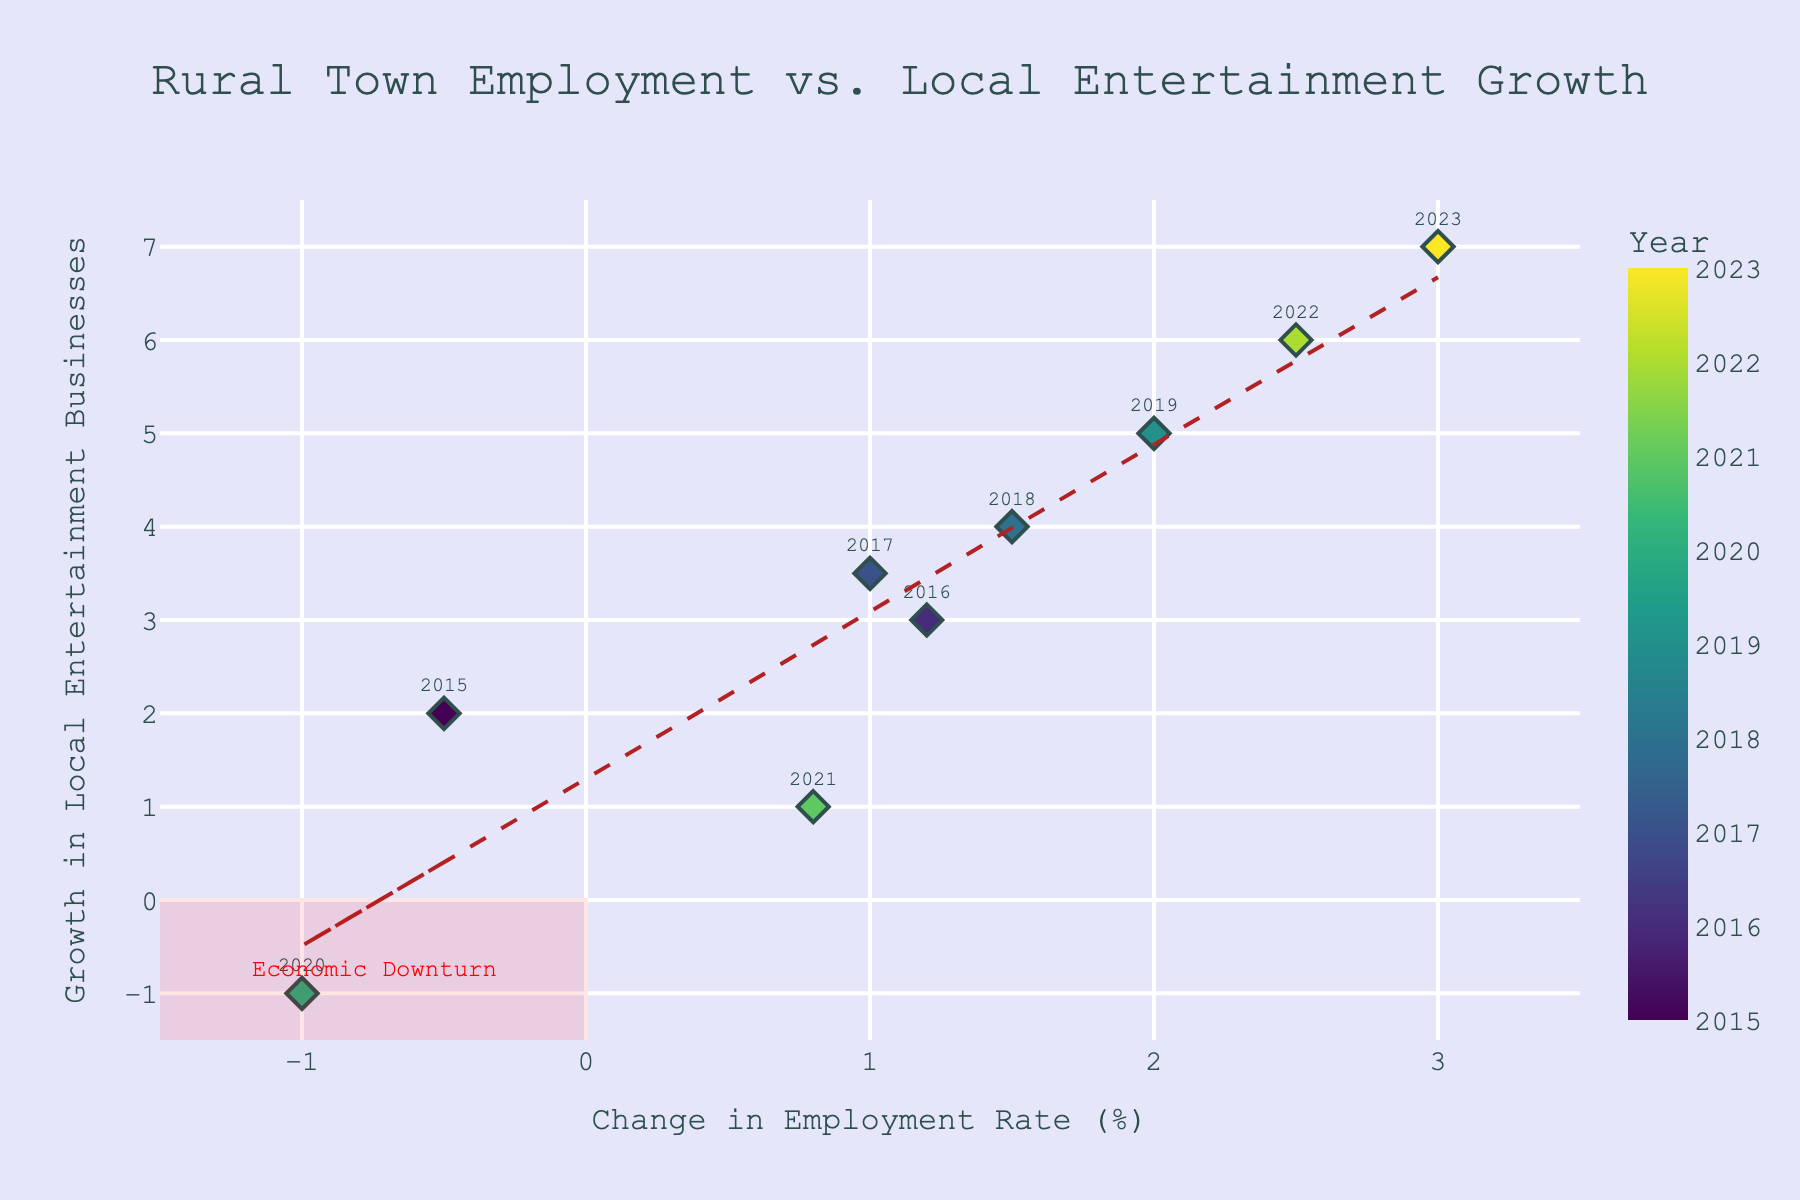What's the title of the figure? The title is clearly displayed at the top of the figure and is meant to provide a summary of what the plot is about. Here, the title is "Rural Town Employment vs. Local Entertainment Growth."
Answer: Rural Town Employment vs. Local Entertainment Growth What are the axes labels? The axes labels are found along the horizontal (x) and vertical (y) axes. The x-axis label is "Change in Employment Rate (%)" and the y-axis label is "Growth in Local Entertainment Businesses."
Answer: Change in Employment Rate (%) and Growth in Local Entertainment Businesses How many data points are there in the figure? Count all the individual markers (diamonds) on the plot. Each point represents a year with corresponding employment rate change and local entertainment growth. There are nine markers corresponding to the years from 2015 to 2023.
Answer: 9 Which data point indicates the largest growth in local entertainment businesses? Look at the y-axis to find the highest value reached by any marker. The highest point on the y-axis is 7, which corresponds to the year 2023.
Answer: 2023 In which year did the employment rate change the most negatively? Look on the x-axis for the data point with the smallest value. The point at -1.0 represents the largest negative change and corresponds to the year 2020.
Answer: 2020 What is the trend shown by the trend line? Observe the trend line added to the scatter plot. The general direction of the line informs us about the relationship between the x and y variables. Here, the trend line is upward sloping from left to right, indicating a positive relationship between employment rate change and local entertainment growth.
Answer: Positive relationship What is the range of the x-axis and y-axis in the plot? Check the start and end points of both axes. The x-axis ranges from -1.5 to 3.5, and the y-axis ranges from -1.5 to 7.5.
Answer: x: -1.5 to 3.5, y: -1.5 to 7.5 How many years experienced a positive change in employment rate? Look at all the data points and count how many have x-values (change in employment rate) greater than 0. These years are 2016, 2017, 2018, 2019, 2021, 2022, and 2023, making a total of seven years.
Answer: 7 Why is the area marked in red at the bottom left? The red rectangle in the bottom left quadrant highlights an area of concern, particularly where both the employment rate change and local entertainment growth are negative. This is labeled as an "Economic Downturn."
Answer: Economic Downturn Which year shows a growth in local entertainment businesses despite a decline in employment rate? Identify data points where the y-values (growth in local entertainment) are positive while the x-values (employment rate change) are negative. The only such data point here corresponds to the year 2015.
Answer: 2015 